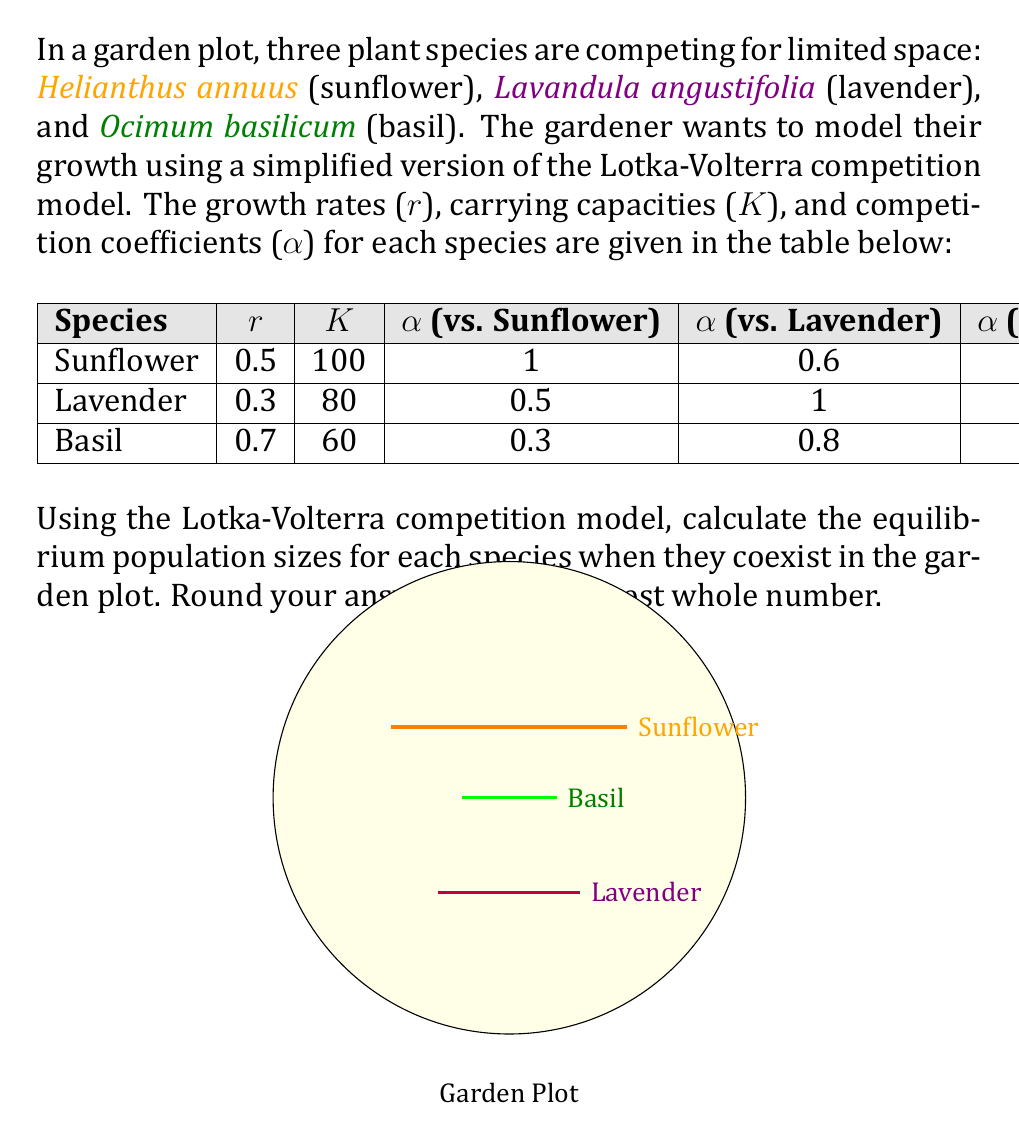Could you help me with this problem? To solve this problem, we'll use the Lotka-Volterra competition model for three species:

$$\frac{dN_1}{dt} = r_1N_1\left(1 - \frac{N_1 + \alpha_{12}N_2 + \alpha_{13}N_3}{K_1}\right)$$
$$\frac{dN_2}{dt} = r_2N_2\left(1 - \frac{N_2 + \alpha_{21}N_1 + \alpha_{23}N_3}{K_2}\right)$$
$$\frac{dN_3}{dt} = r_3N_3\left(1 - \frac{N_3 + \alpha_{31}N_1 + \alpha_{32}N_2}{K_3}\right)$$

Where:
- $N_1$, $N_2$, and $N_3$ are the population sizes of sunflower, lavender, and basil respectively
- $r_1$, $r_2$, and $r_3$ are their growth rates
- $K_1$, $K_2$, and $K_3$ are their carrying capacities
- $\alpha_{ij}$ is the competition coefficient of species j on species i

At equilibrium, $\frac{dN_1}{dt} = \frac{dN_2}{dt} = \frac{dN_3}{dt} = 0$. So we can set up the following equations:

$$N_1 + 0.6N_2 + 0.4N_3 = 100$$
$$0.5N_1 + N_2 + 0.7N_3 = 80$$
$$0.3N_1 + 0.8N_2 + N_3 = 60$$

Solving this system of linear equations:

1) Multiply the first equation by 2 and subtract the second equation:
   $$1.5N_1 + 0.2N_2 + 0.1N_3 = 120$$

2) Multiply the first equation by 10/3 and subtract the third equation:
   $$3N_1 + 0.2N_2 - 0.33N_3 = 273.33$$

3) Subtract equation 1 from equation 2:
   $$1.5N_1 - 0.33N_3 = 153.33$$

4) From this, we can express $N_1$ in terms of $N_3$:
   $$N_1 = 102.22 + 0.22N_3$$

5) Substitute this into the third original equation:
   $$0.3(102.22 + 0.22N_3) + 0.8N_2 + N_3 = 60$$
   $$30.67 + 0.066N_3 + 0.8N_2 + N_3 = 60$$
   $$0.8N_2 + 1.066N_3 = 29.33$$

6) Substitute $N_1$ expression into the first original equation:
   $$(102.22 + 0.22N_3) + 0.6N_2 + 0.4N_3 = 100$$
   $$0.6N_2 + 0.62N_3 = -2.22$$

7) Solve these last two equations for $N_2$ and $N_3$:
   $$N_2 \approx 44.57$$
   $$N_3 \approx 21.43$$

8) Finally, calculate $N_1$:
   $$N_1 = 102.22 + 0.22(21.43) \approx 106.93$$

Rounding to the nearest whole number:
$N_1 = 107$, $N_2 = 45$, $N_3 = 21$
Answer: Sunflower: 107, Lavender: 45, Basil: 21 